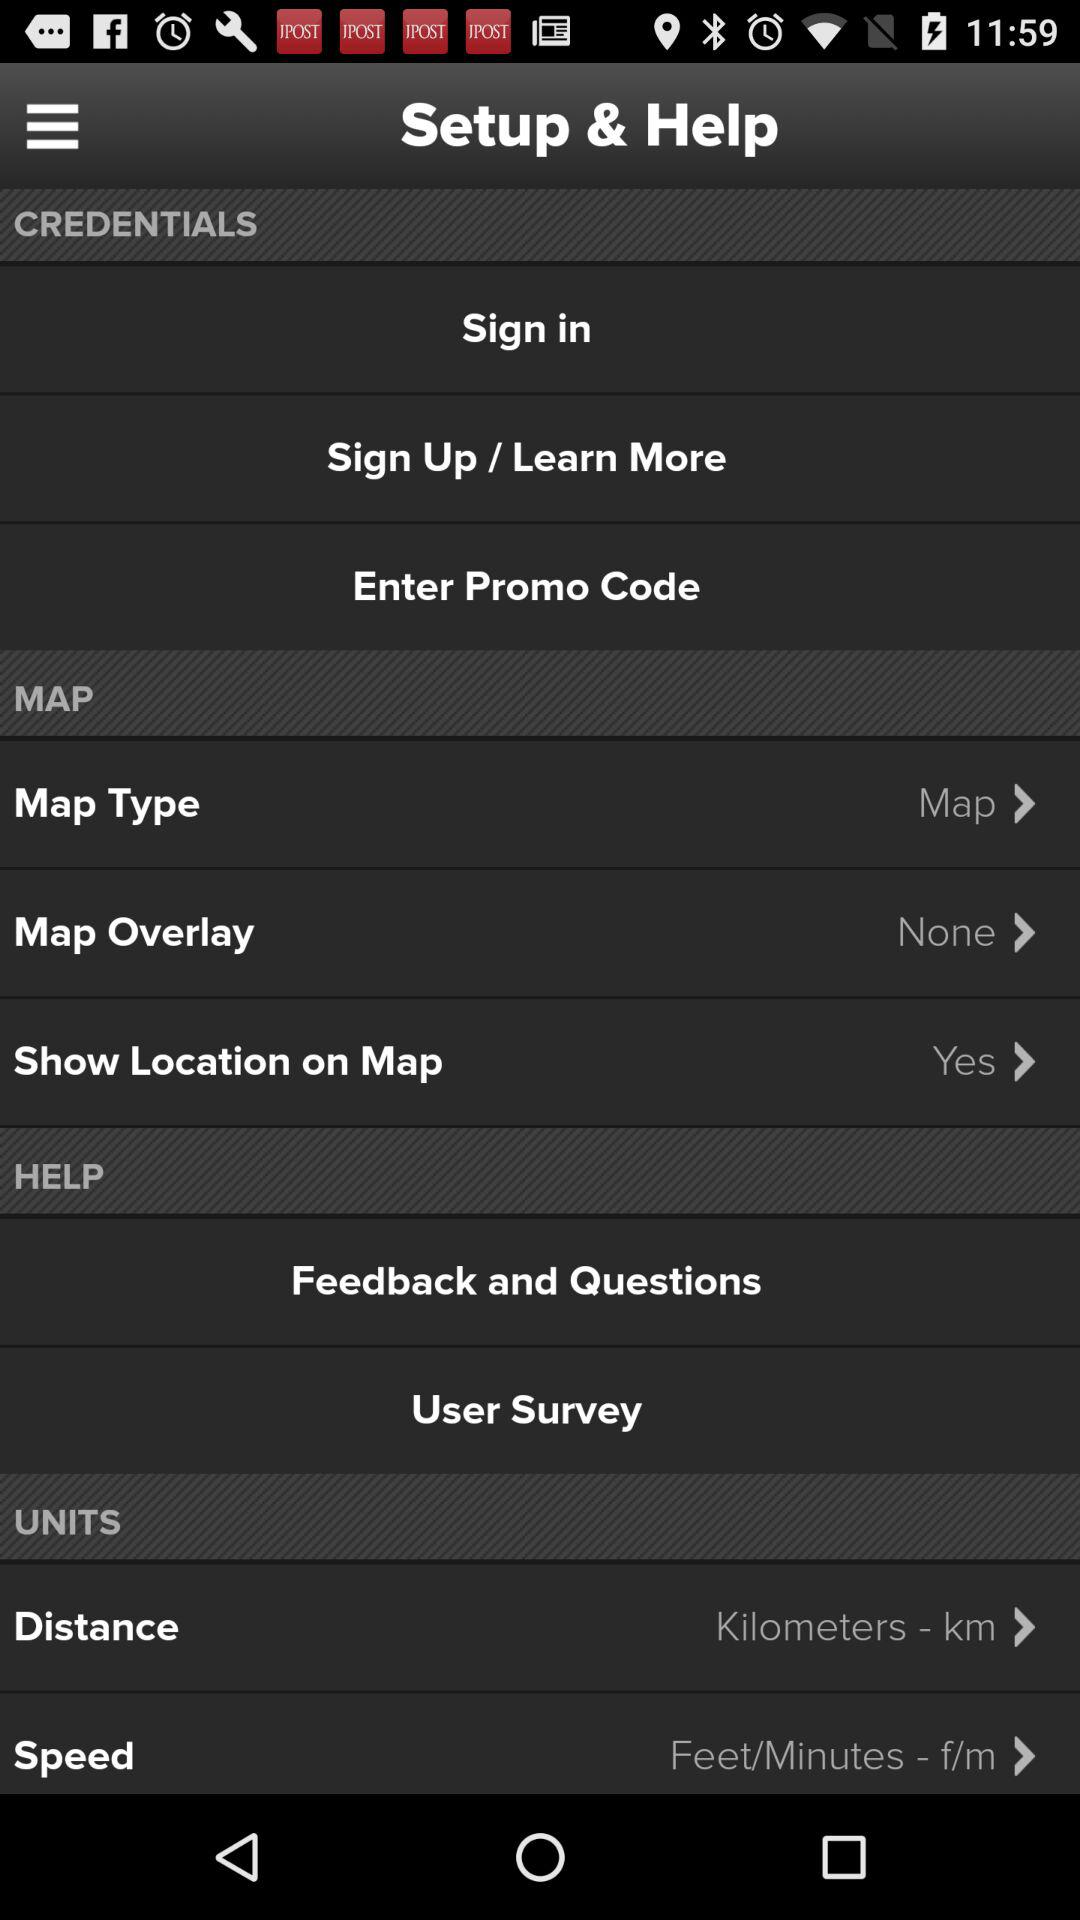Is there any map overlay? There is no map overlay. 